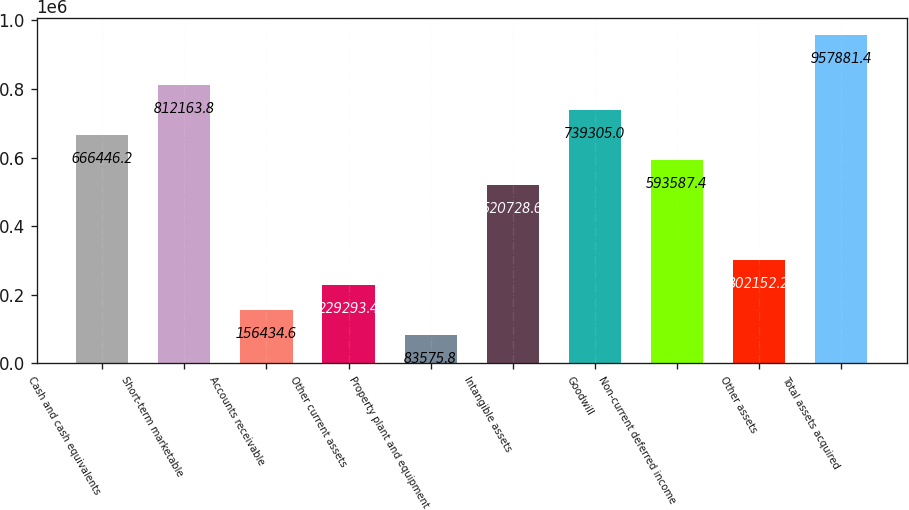Convert chart to OTSL. <chart><loc_0><loc_0><loc_500><loc_500><bar_chart><fcel>Cash and cash equivalents<fcel>Short-term marketable<fcel>Accounts receivable<fcel>Other current assets<fcel>Property plant and equipment<fcel>Intangible assets<fcel>Goodwill<fcel>Non-current deferred income<fcel>Other assets<fcel>Total assets acquired<nl><fcel>666446<fcel>812164<fcel>156435<fcel>229293<fcel>83575.8<fcel>520729<fcel>739305<fcel>593587<fcel>302152<fcel>957881<nl></chart> 